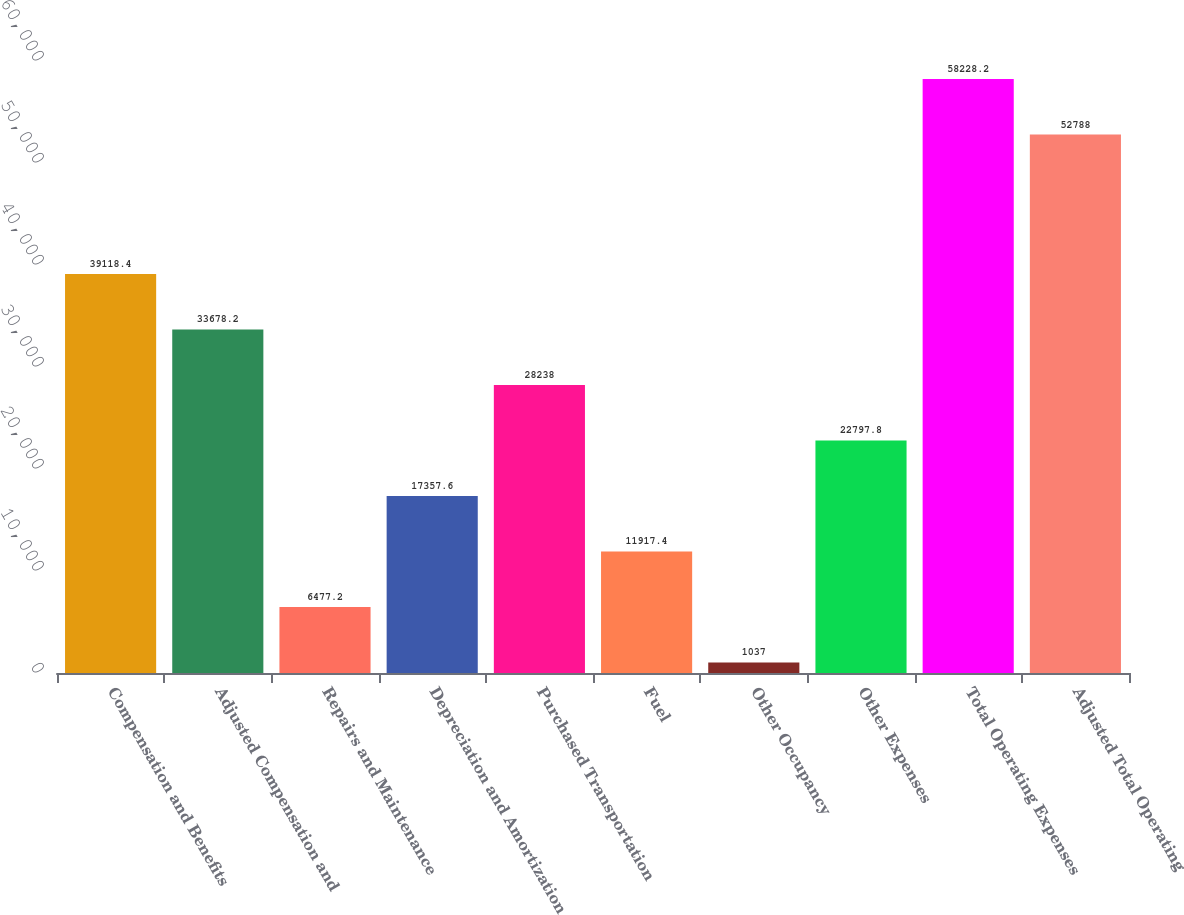Convert chart. <chart><loc_0><loc_0><loc_500><loc_500><bar_chart><fcel>Compensation and Benefits<fcel>Adjusted Compensation and<fcel>Repairs and Maintenance<fcel>Depreciation and Amortization<fcel>Purchased Transportation<fcel>Fuel<fcel>Other Occupancy<fcel>Other Expenses<fcel>Total Operating Expenses<fcel>Adjusted Total Operating<nl><fcel>39118.4<fcel>33678.2<fcel>6477.2<fcel>17357.6<fcel>28238<fcel>11917.4<fcel>1037<fcel>22797.8<fcel>58228.2<fcel>52788<nl></chart> 